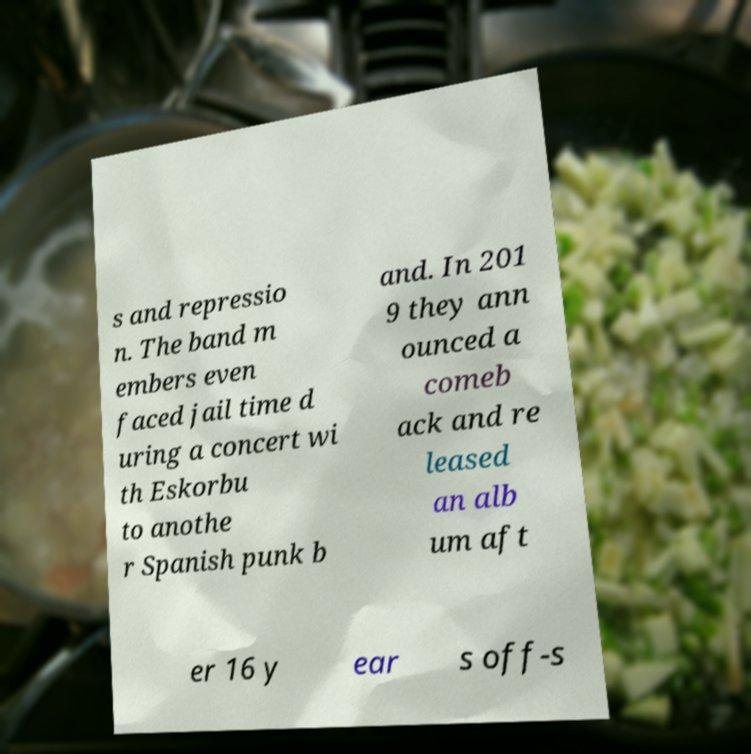Please read and relay the text visible in this image. What does it say? s and repressio n. The band m embers even faced jail time d uring a concert wi th Eskorbu to anothe r Spanish punk b and. In 201 9 they ann ounced a comeb ack and re leased an alb um aft er 16 y ear s off-s 